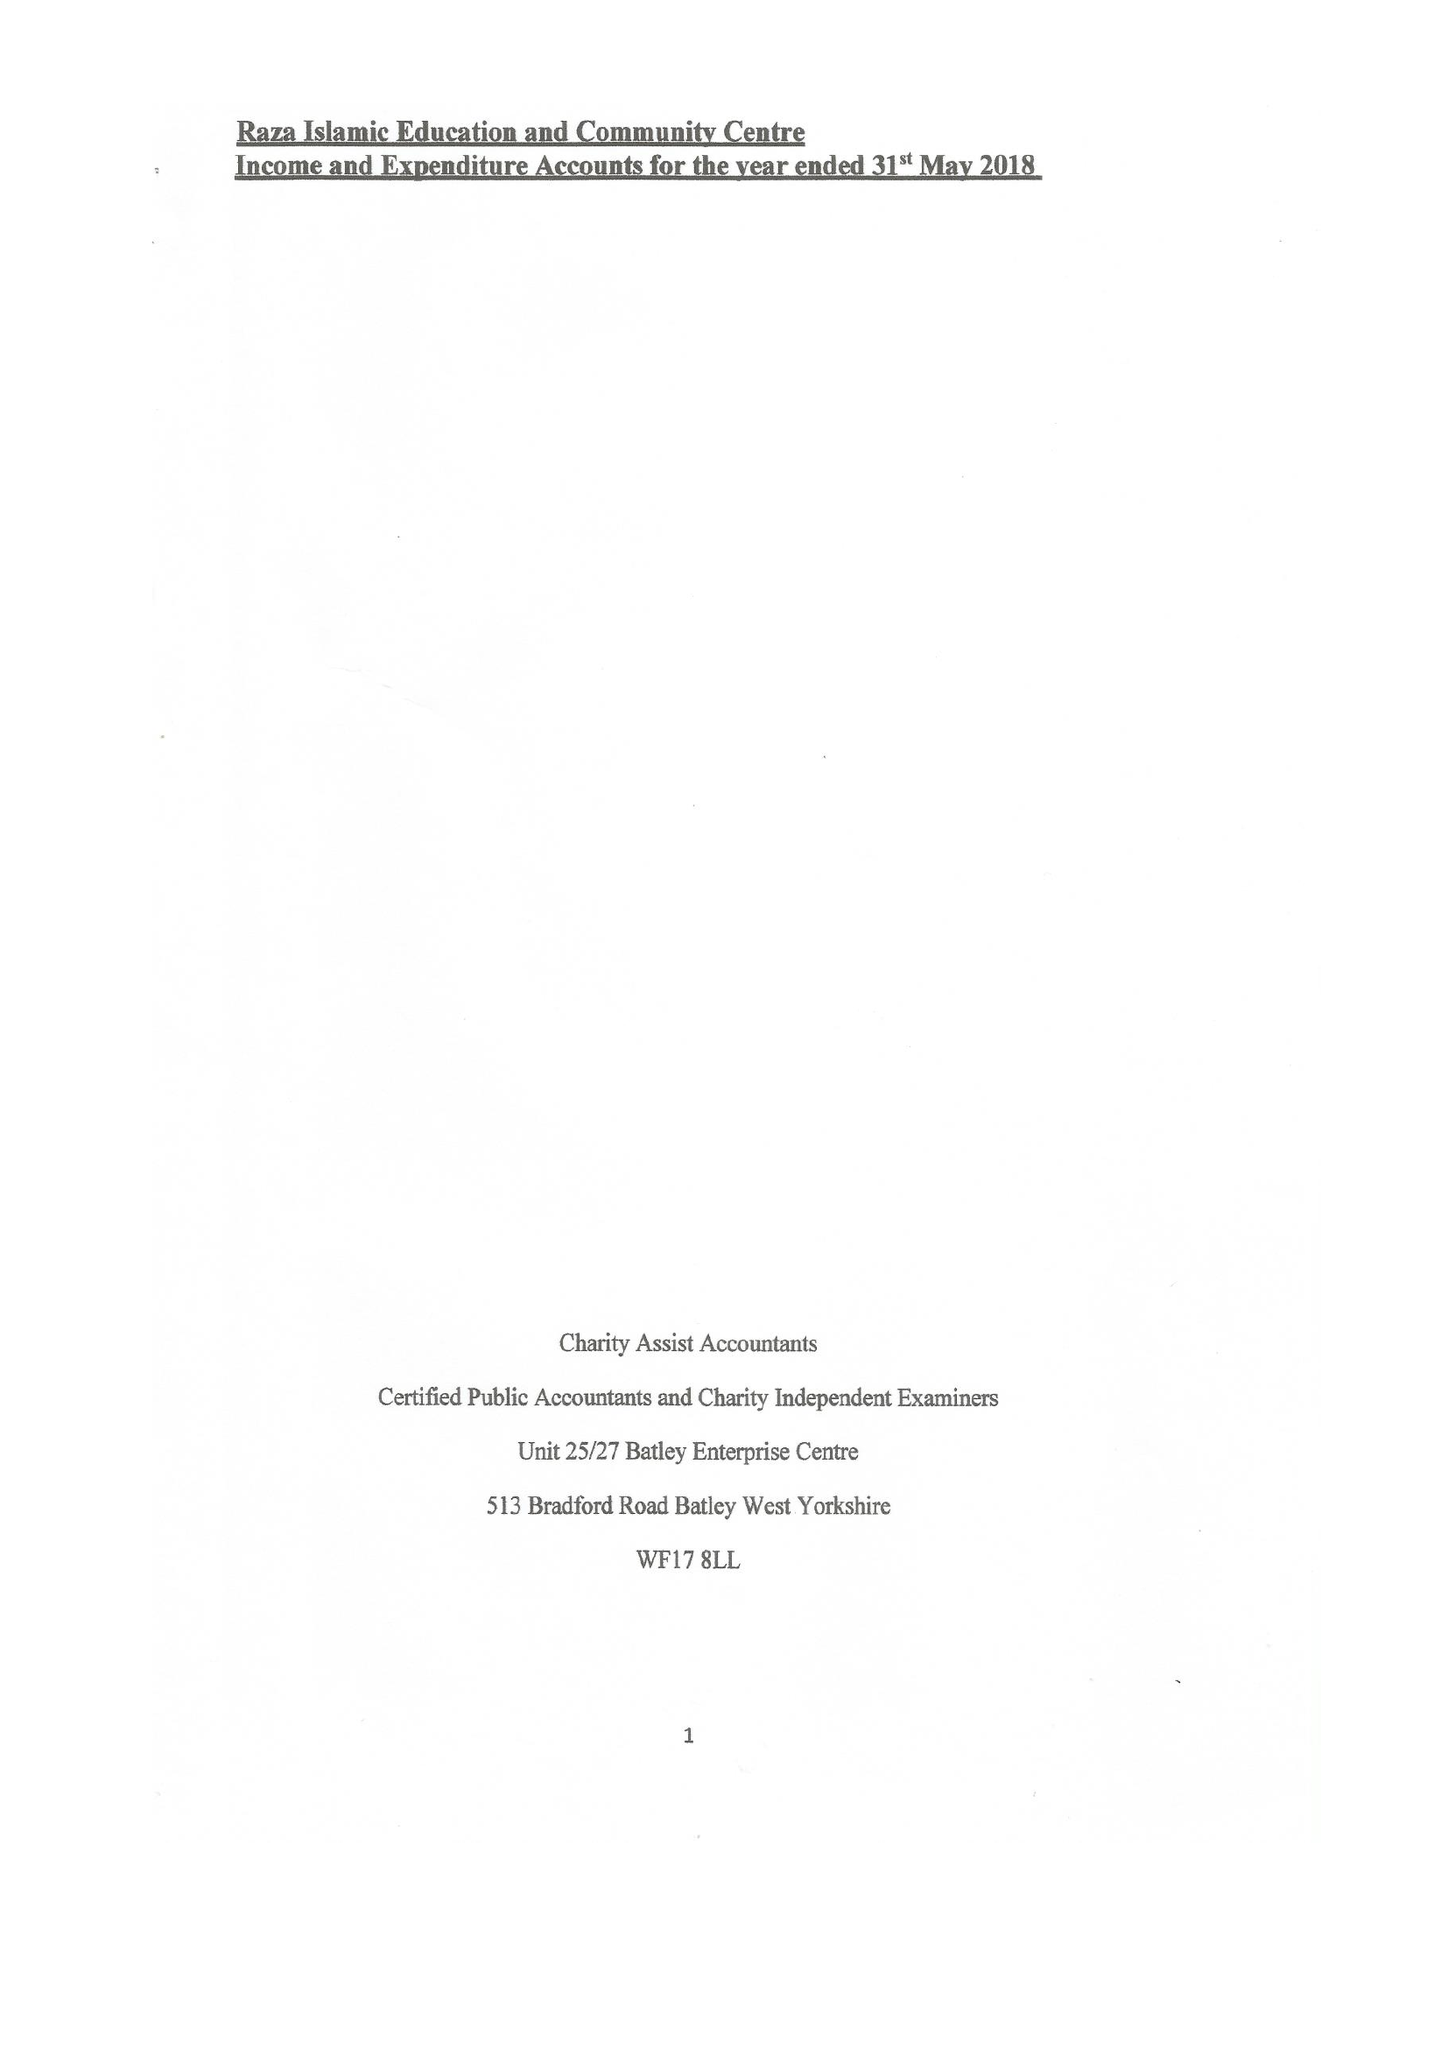What is the value for the spending_annually_in_british_pounds?
Answer the question using a single word or phrase. 35177.00 